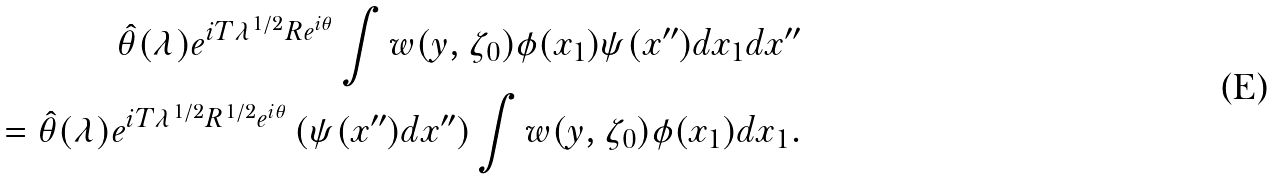Convert formula to latex. <formula><loc_0><loc_0><loc_500><loc_500>{ \hat { \theta } } ( \lambda ) e ^ { i T \lambda ^ { 1 / 2 } R e ^ { i \theta } } \int w ( y , \zeta _ { 0 } ) \phi ( x _ { 1 } ) \psi ( x ^ { \prime \prime } ) d x _ { 1 } d x ^ { \prime \prime } \\ = { \hat { \theta } } ( \lambda ) e ^ { i T \lambda ^ { 1 / 2 } R ^ { 1 / 2 } e ^ { i \theta } } \left ( \psi ( x ^ { \prime \prime } ) d x ^ { \prime \prime } \right ) \int w ( y , \zeta _ { 0 } ) \phi ( x _ { 1 } ) d x _ { 1 } .</formula> 